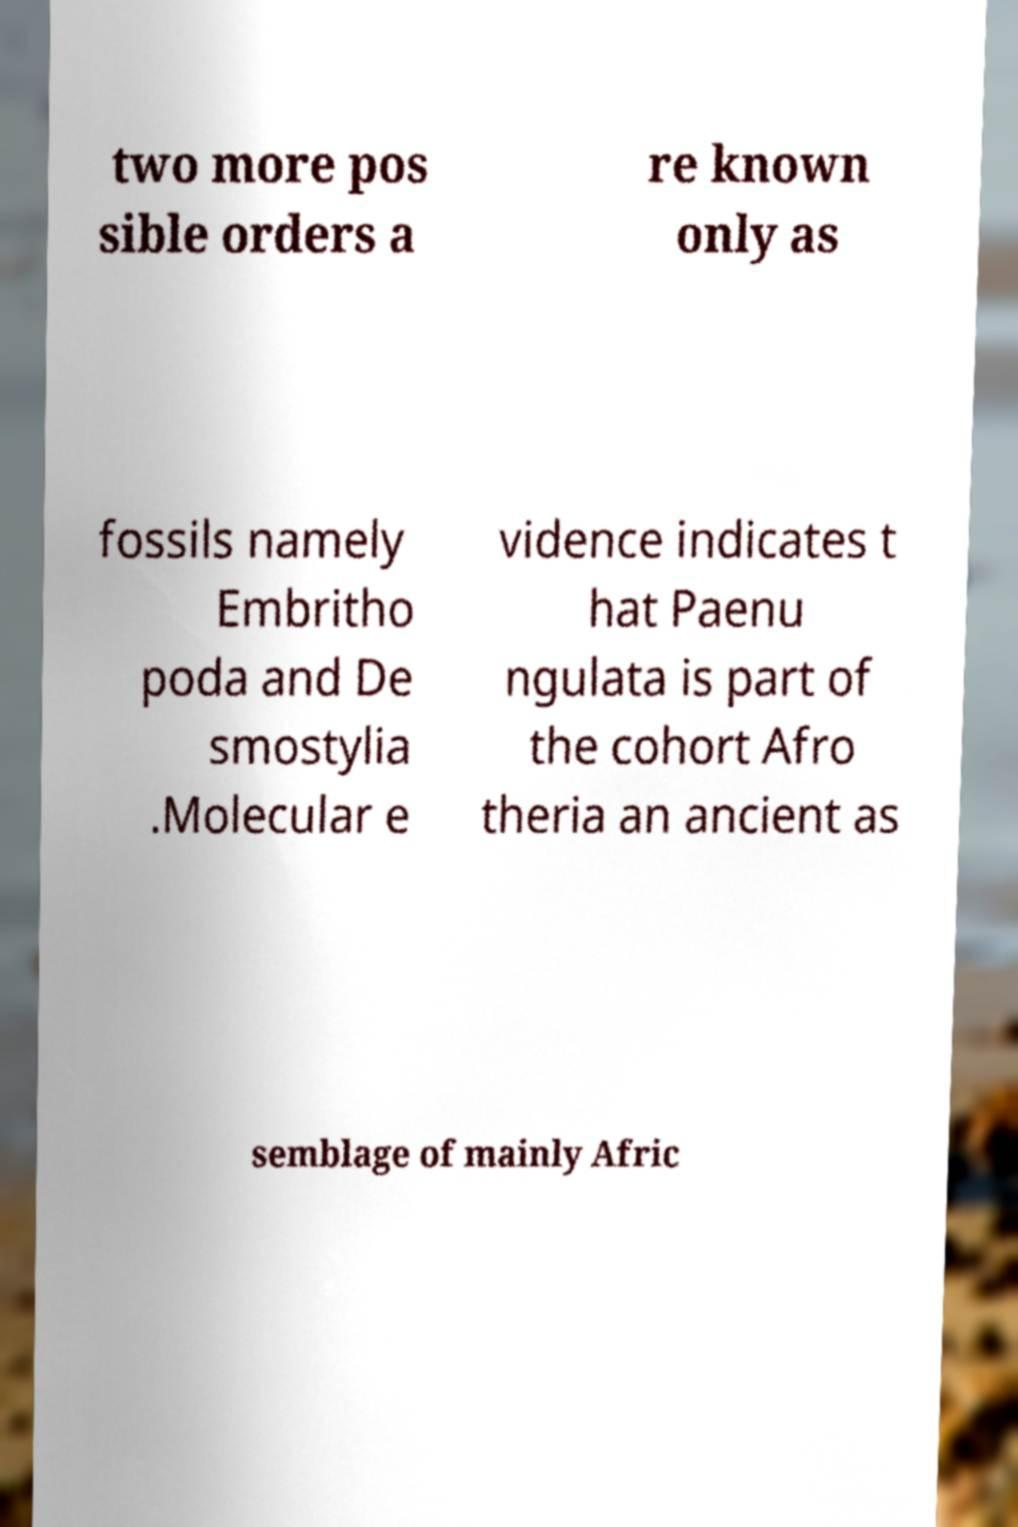I need the written content from this picture converted into text. Can you do that? two more pos sible orders a re known only as fossils namely Embritho poda and De smostylia .Molecular e vidence indicates t hat Paenu ngulata is part of the cohort Afro theria an ancient as semblage of mainly Afric 